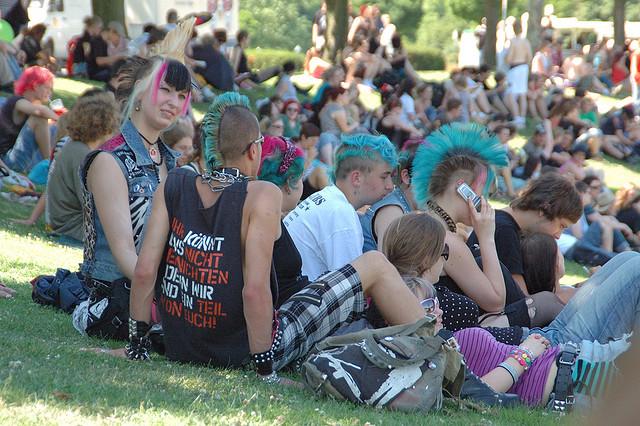What are the people sitting on?
Write a very short answer. Grass. Do these people appear to be relaxed?
Answer briefly. Yes. What do you call that hairstyle?
Answer briefly. Mohawk. Is this a bad hair convention?
Answer briefly. No. 